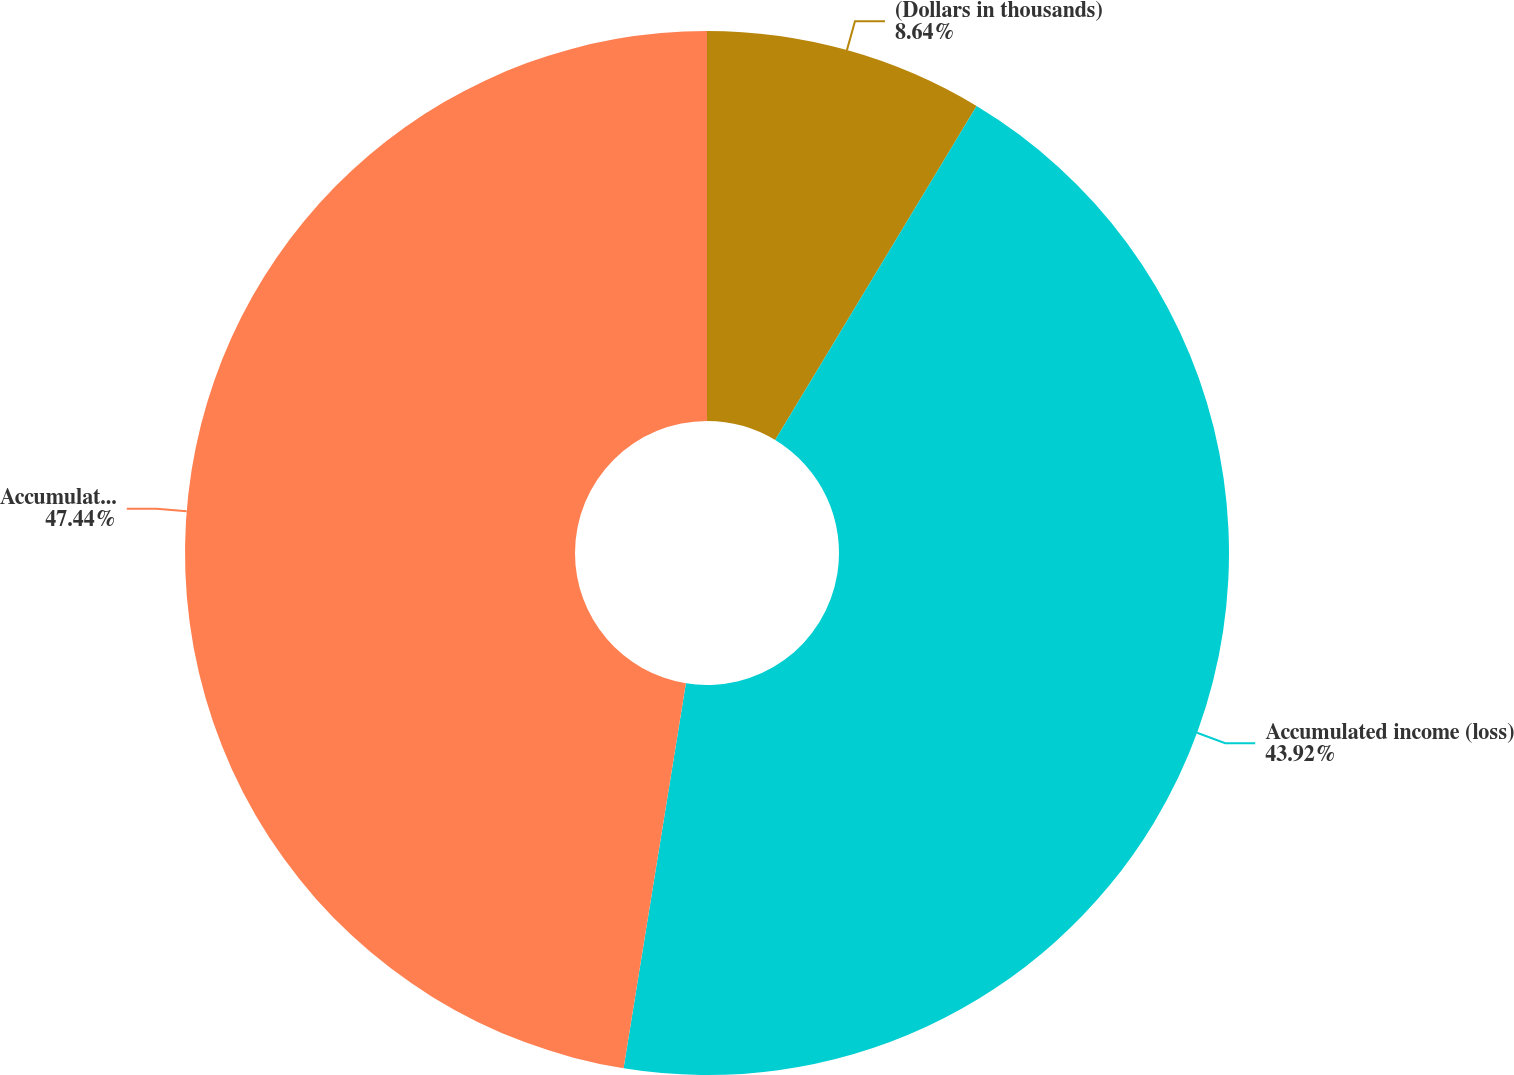Convert chart to OTSL. <chart><loc_0><loc_0><loc_500><loc_500><pie_chart><fcel>(Dollars in thousands)<fcel>Accumulated income (loss)<fcel>Accumulated other<nl><fcel>8.64%<fcel>43.92%<fcel>47.45%<nl></chart> 